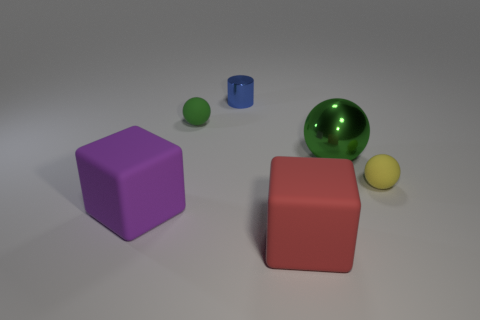What shape is the small thing behind the green matte ball?
Your response must be concise. Cylinder. There is another shiny object that is the same size as the red thing; what is its color?
Give a very brief answer. Green. There is a large red matte thing; is it the same shape as the tiny matte object on the left side of the large shiny ball?
Make the answer very short. No. What is the material of the green thing right of the small rubber ball that is on the left side of the green sphere to the right of the cylinder?
Provide a short and direct response. Metal. How many small things are rubber blocks or red rubber things?
Make the answer very short. 0. What number of other objects are the same size as the yellow rubber ball?
Offer a very short reply. 2. Does the big matte thing right of the blue cylinder have the same shape as the large purple matte object?
Provide a short and direct response. Yes. The other rubber thing that is the same shape as the green matte object is what color?
Provide a short and direct response. Yellow. Are there any other things that are the same shape as the big red matte thing?
Offer a very short reply. Yes. Is the number of big metallic spheres that are on the left side of the blue metallic cylinder the same as the number of large balls?
Offer a very short reply. No. 